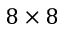Convert formula to latex. <formula><loc_0><loc_0><loc_500><loc_500>8 \times 8</formula> 